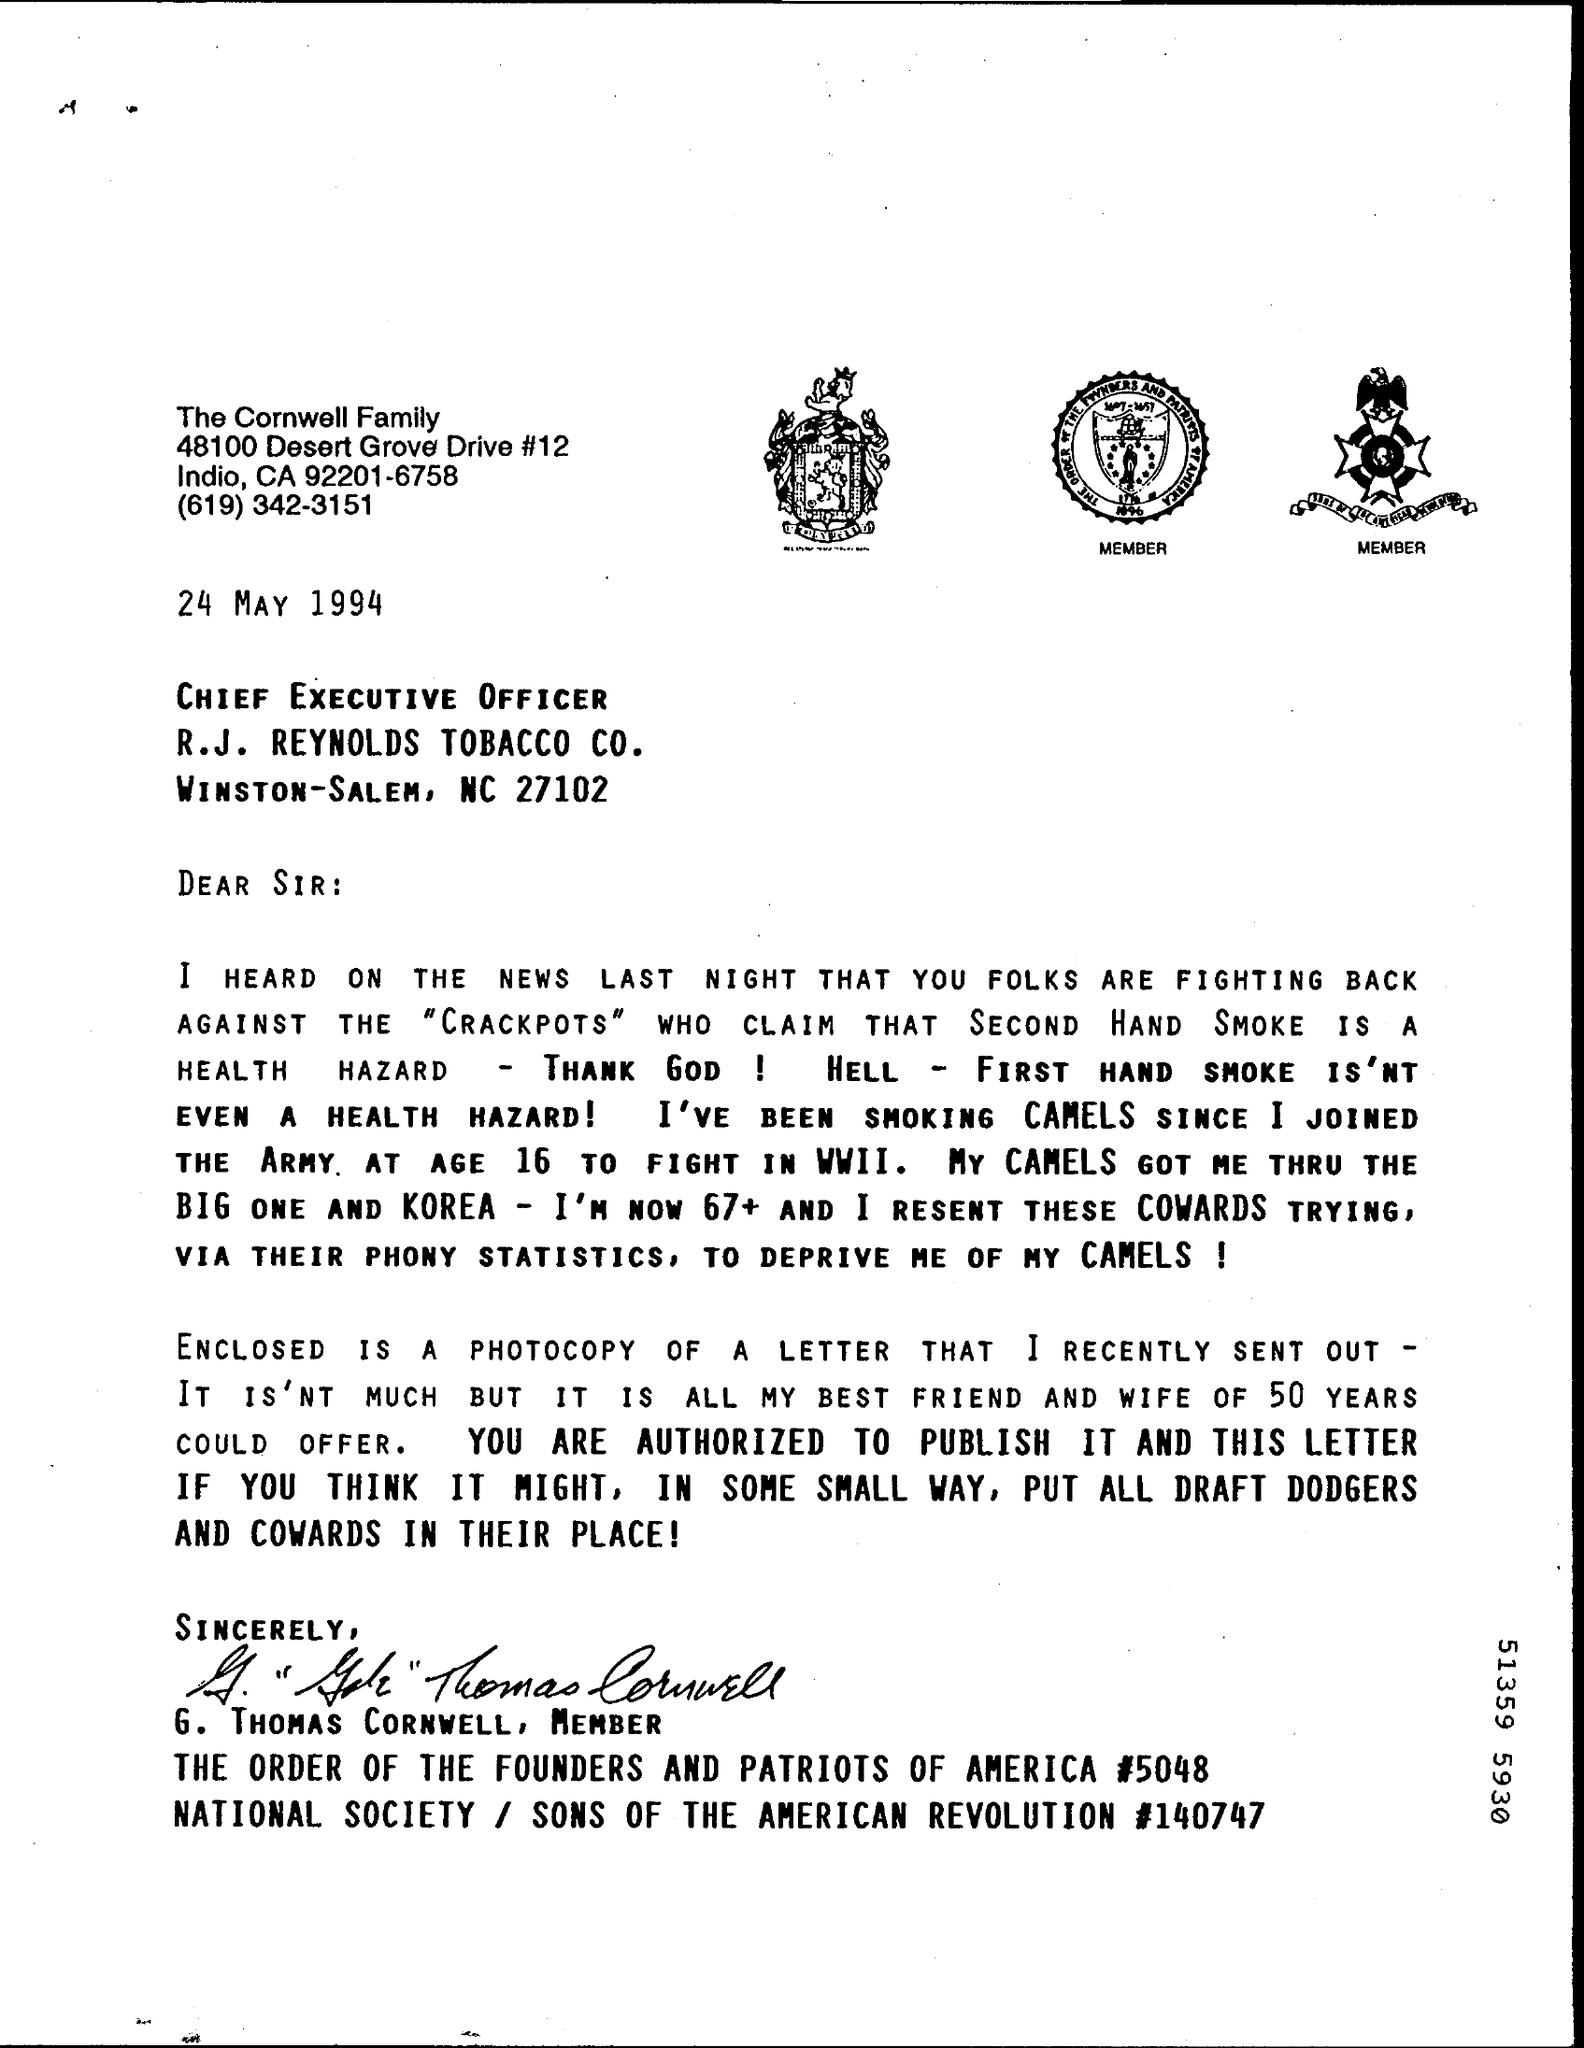Specify some key components in this picture. The Cornwell Family is the sender of this letter. The letter is dated on May 24, 1994. 